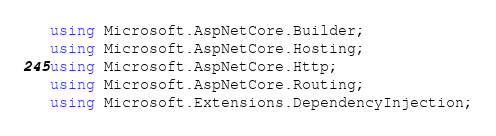<code> <loc_0><loc_0><loc_500><loc_500><_C#_>using Microsoft.AspNetCore.Builder;
using Microsoft.AspNetCore.Hosting;
using Microsoft.AspNetCore.Http;
using Microsoft.AspNetCore.Routing;
using Microsoft.Extensions.DependencyInjection;</code> 